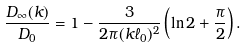<formula> <loc_0><loc_0><loc_500><loc_500>\frac { D _ { \infty } ( k ) } { D _ { 0 } } = 1 - \frac { 3 } { 2 \pi ( k \ell _ { 0 } ) ^ { 2 } } \left ( \ln 2 + \frac { \pi } { 2 } \right ) .</formula> 